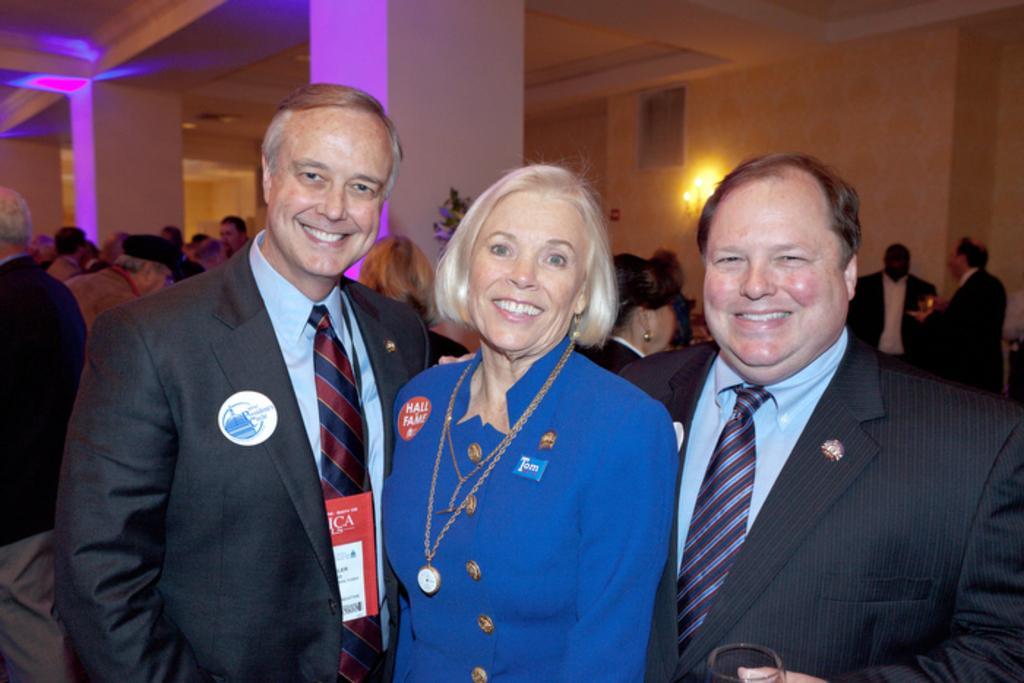Describe this image in one or two sentences. In this image there are three people standing with a smile on their face, behind them there are a few people standing and there are pillars. At the top of the image there is a ceiling. In the background there is a wall and a lamp. 